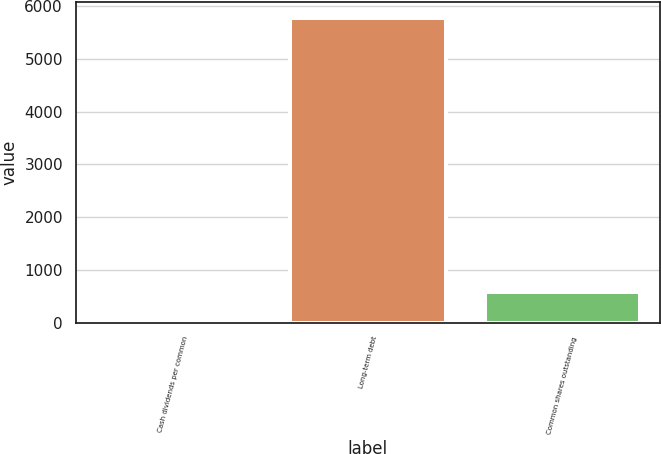Convert chart. <chart><loc_0><loc_0><loc_500><loc_500><bar_chart><fcel>Cash dividends per common<fcel>Long-term debt<fcel>Common shares outstanding<nl><fcel>0.3<fcel>5785<fcel>578.77<nl></chart> 